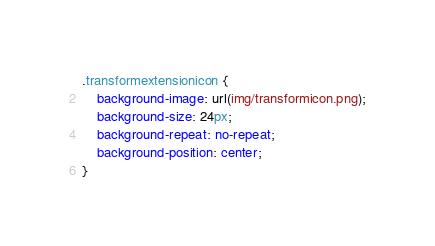Convert code to text. <code><loc_0><loc_0><loc_500><loc_500><_CSS_>.transformextensionicon {
    background-image: url(img/transformicon.png);
    background-size: 24px;
    background-repeat: no-repeat;
    background-position: center;
}</code> 